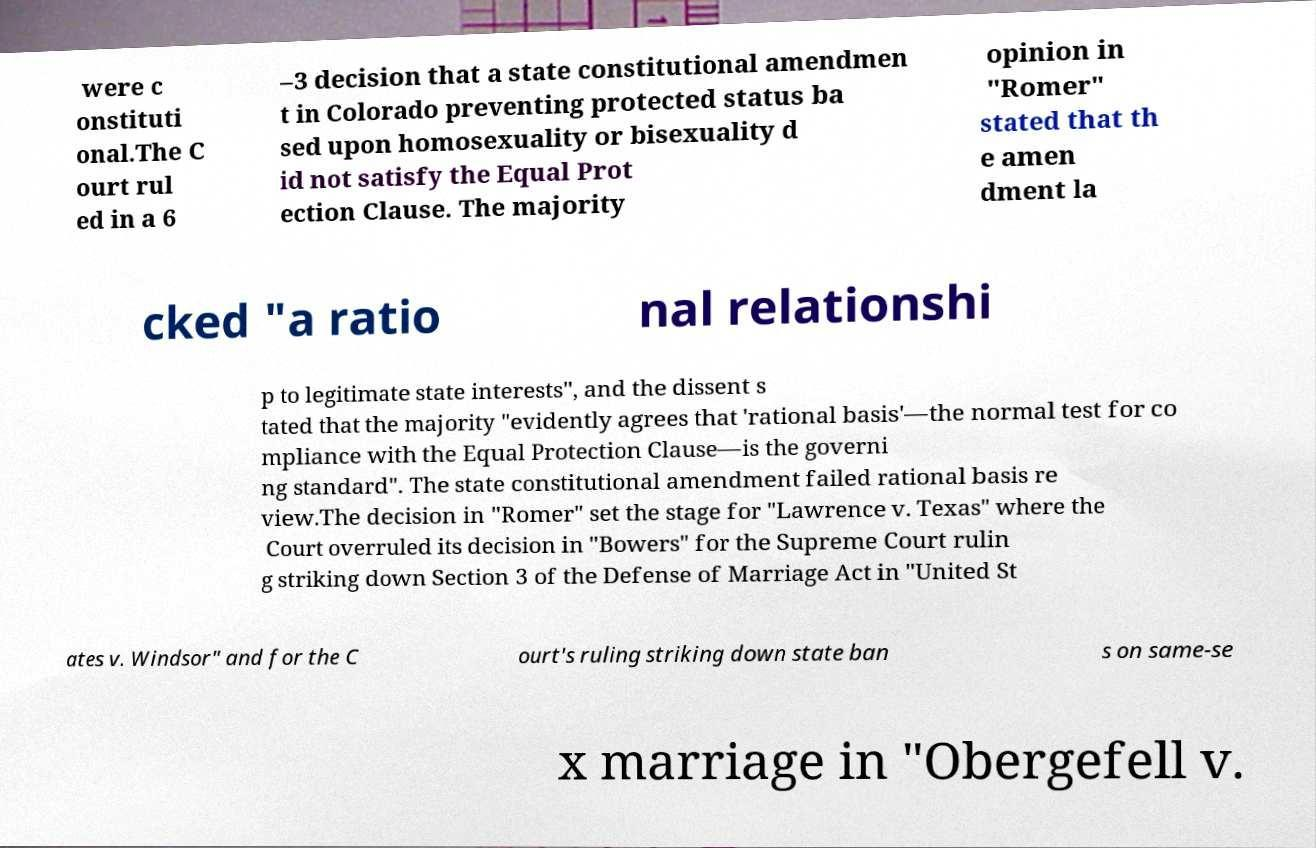For documentation purposes, I need the text within this image transcribed. Could you provide that? were c onstituti onal.The C ourt rul ed in a 6 –3 decision that a state constitutional amendmen t in Colorado preventing protected status ba sed upon homosexuality or bisexuality d id not satisfy the Equal Prot ection Clause. The majority opinion in "Romer" stated that th e amen dment la cked "a ratio nal relationshi p to legitimate state interests", and the dissent s tated that the majority "evidently agrees that 'rational basis'—the normal test for co mpliance with the Equal Protection Clause—is the governi ng standard". The state constitutional amendment failed rational basis re view.The decision in "Romer" set the stage for "Lawrence v. Texas" where the Court overruled its decision in "Bowers" for the Supreme Court rulin g striking down Section 3 of the Defense of Marriage Act in "United St ates v. Windsor" and for the C ourt's ruling striking down state ban s on same-se x marriage in "Obergefell v. 